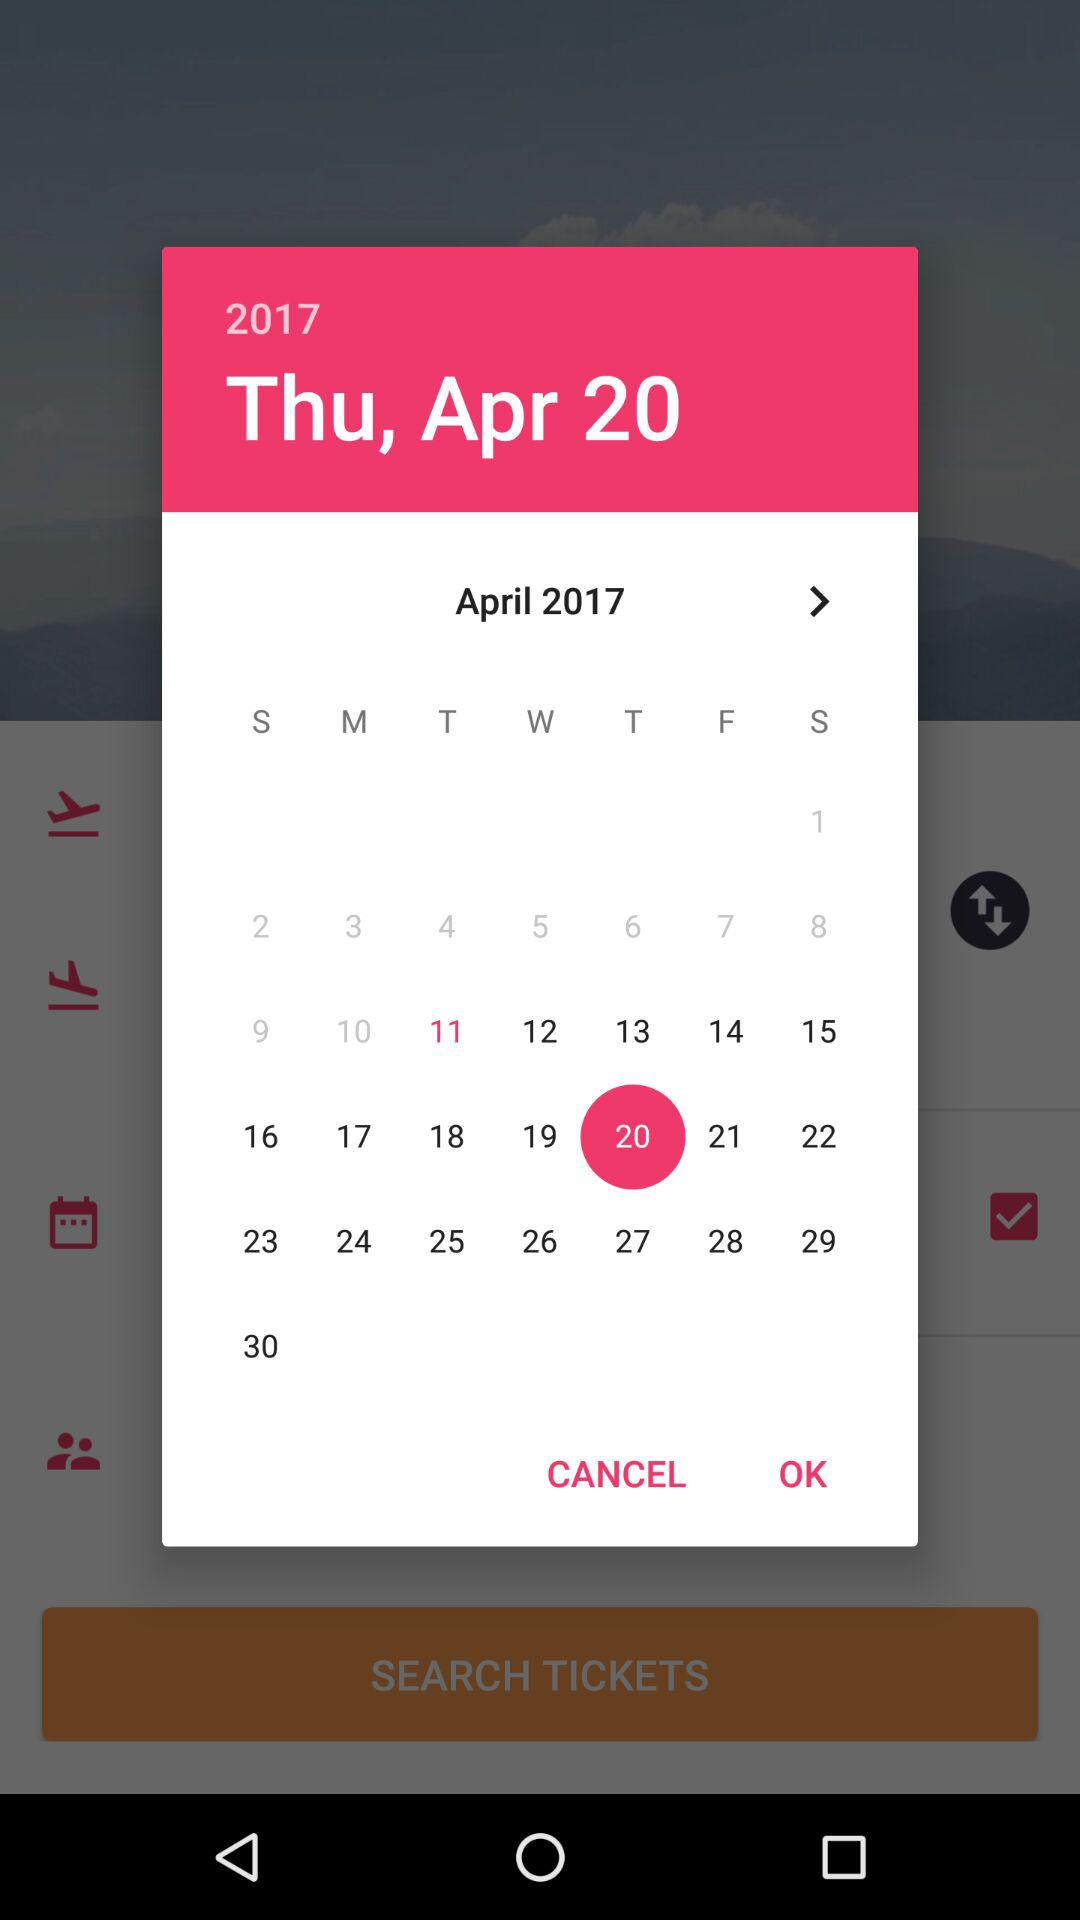What is the selected date? The selected date is Thursday, 20 April 2017. 